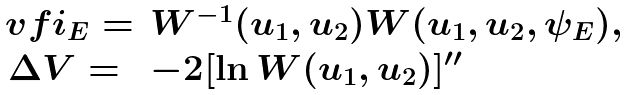Convert formula to latex. <formula><loc_0><loc_0><loc_500><loc_500>\begin{array} { c l } \ v f i _ { E } = & W ^ { - 1 } ( u _ { 1 } , u _ { 2 } ) W ( u _ { 1 } , u _ { 2 } , \psi _ { E } ) , \\ \Delta V = & - 2 [ \ln W ( u _ { 1 } , u _ { 2 } ) ] ^ { \prime \prime } \end{array}</formula> 